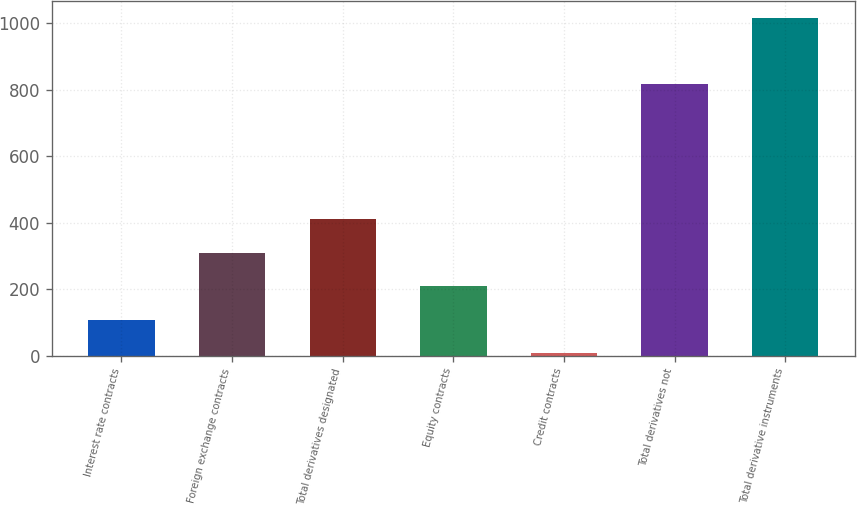Convert chart to OTSL. <chart><loc_0><loc_0><loc_500><loc_500><bar_chart><fcel>Interest rate contracts<fcel>Foreign exchange contracts<fcel>Total derivatives designated<fcel>Equity contracts<fcel>Credit contracts<fcel>Total derivatives not<fcel>Total derivative instruments<nl><fcel>107.79<fcel>309.77<fcel>410.76<fcel>208.78<fcel>6.8<fcel>816.4<fcel>1016.7<nl></chart> 